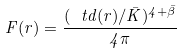Convert formula to latex. <formula><loc_0><loc_0><loc_500><loc_500>F ( r ) = \frac { ( \ t d ( r ) / \bar { K } ) ^ { 4 + \bar { \beta } } } { 4 \pi }</formula> 